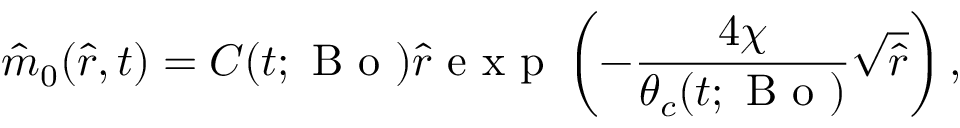Convert formula to latex. <formula><loc_0><loc_0><loc_500><loc_500>\hat { m } _ { 0 } ( \hat { r } , t ) = C ( t ; B o ) \hat { r } e x p \left ( - \frac { 4 \chi } { \theta _ { c } ( t ; B o ) } \sqrt { \hat { r } } \right ) ,</formula> 